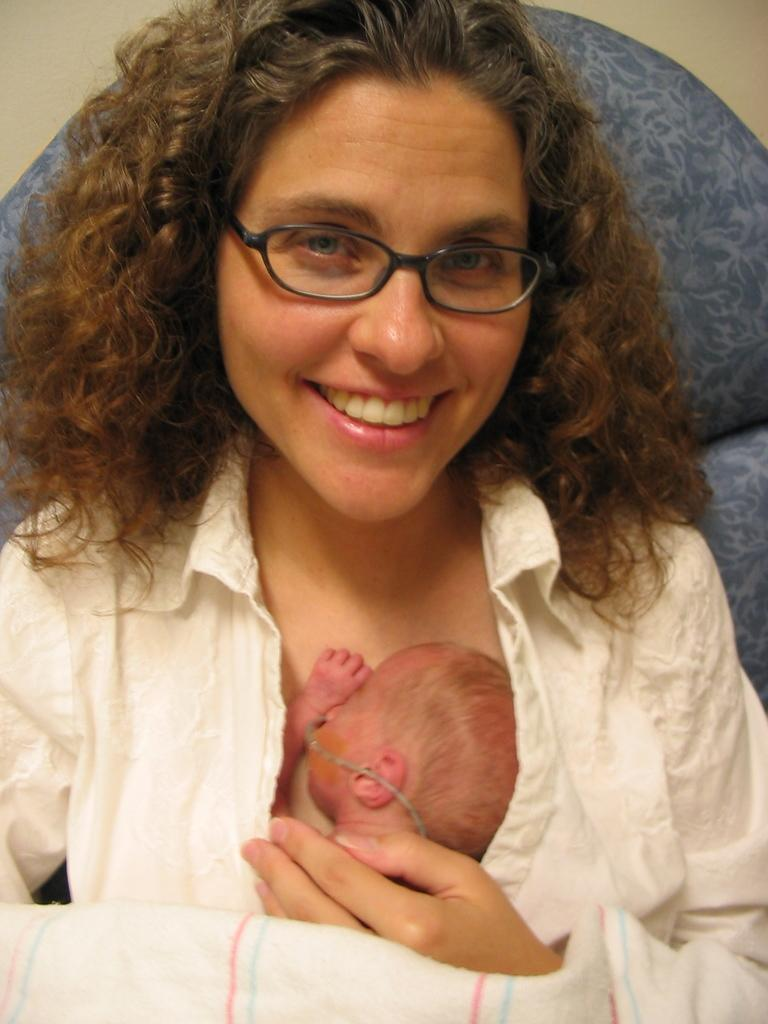Who is the main subject in the image? There is a lady in the image. What is the lady wearing? The lady is wearing specs. What is the lady holding in the image? The lady is holding a baby. What can be seen at the bottom of the image? There is a cloth at the bottom of the image. What is present in the background of the image? There is an object in the background of the image. What type of account does the lady have with the government in the image? There is no mention of an account or the government in the image; it features a lady holding a baby. What type of skin condition is visible on the baby in the image? There is no indication of a skin condition on the baby in the image. 